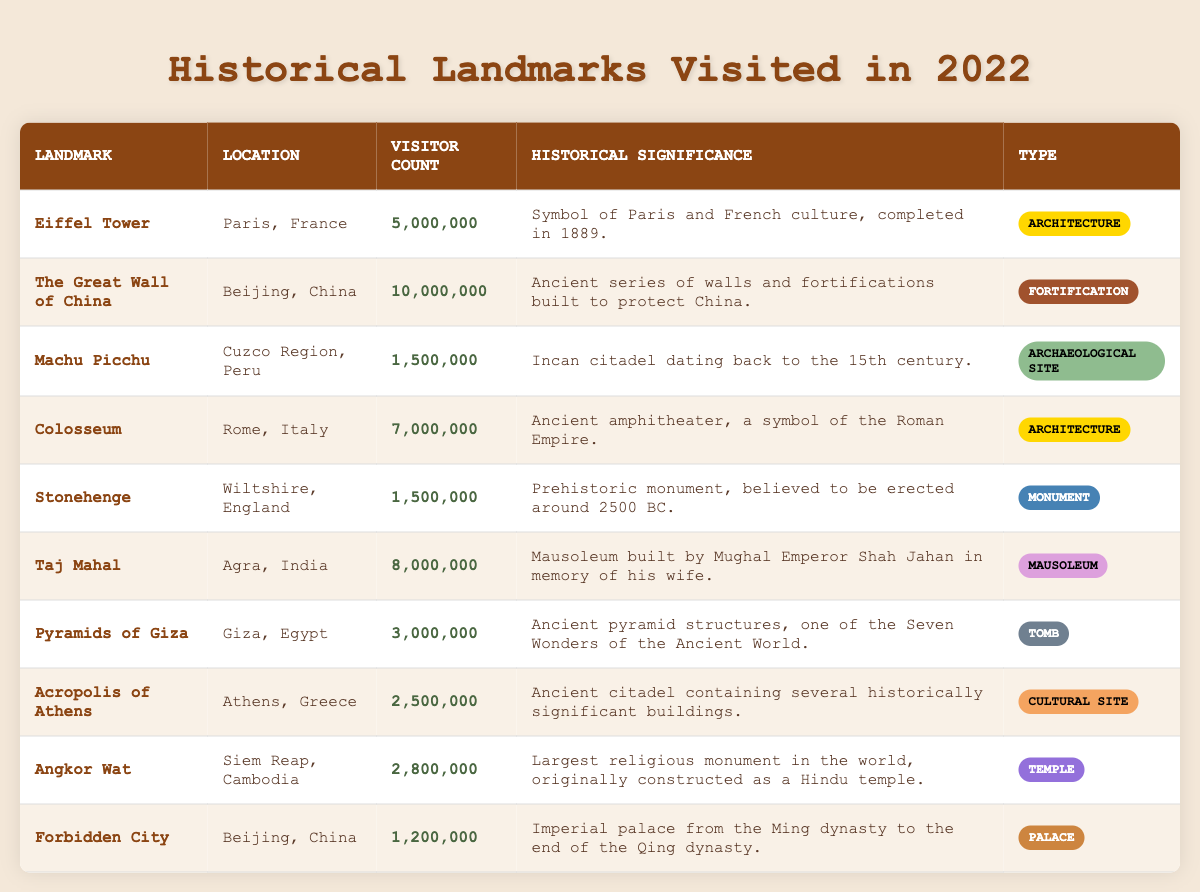What is the historical significance of the Taj Mahal? The table states that the Taj Mahal is a mausoleum built by Mughal Emperor Shah Jahan in memory of his wife.
Answer: Mausoleum built by Mughal Emperor Shah Jahan in memory of his wife Which landmark had the highest visitor count in 2022? The table shows that the Great Wall of China had the highest visitor count at 10,000,000.
Answer: The Great Wall of China How many visitors did the Acropolis of Athens receive compared to the Pyramids of Giza? The Acropolis of Athens had 2,500,000 visitors while the Pyramids of Giza had 3,000,000 visitors. So, the Pyramids had 500,000 more visitors.
Answer: Pyramids of Giza had 500,000 more visitors What type of landmark is Stonehenge? According to the table, Stonehenge is classified as a Monument.
Answer: Monument What is the average visitor count of the archaeological sites listed? The two archaeological sites are Machu Picchu (1,500,000) and Angkor Wat (2,800,000). The sum is 1,500,000 + 2,800,000 = 4,300,000 and the average is 4,300,000 / 2 = 2,150,000.
Answer: 2,150,000 Is the Eiffel Tower classified as a Cultural site? The table categorizes the Eiffel Tower as an Architecture landmark, so it is not a Cultural site.
Answer: No Which two landmarks are located in Beijing, China? The table lists The Great Wall of China and the Forbidden City as landmarks in Beijing, China.
Answer: The Great Wall of China and Forbidden City Calculate the total number of visitors to all landmarks listed. The sum of all visitors is 5,000,000 + 10,000,000 + 1,500,000 + 7,000,000 + 1,500,000 + 8,000,000 + 3,000,000 + 2,500,000 + 2,800,000 + 1,200,000 = 42,500,000.
Answer: 42,500,000 What is the type of landmark for the Forbidden City? The table indicates that the Forbidden City is classified as a Palace.
Answer: Palace Did more than 5 million visitors visit the Taj Mahal? The table shows that the Taj Mahal had 8,000,000 visitors, which is greater than 5 million.
Answer: Yes 